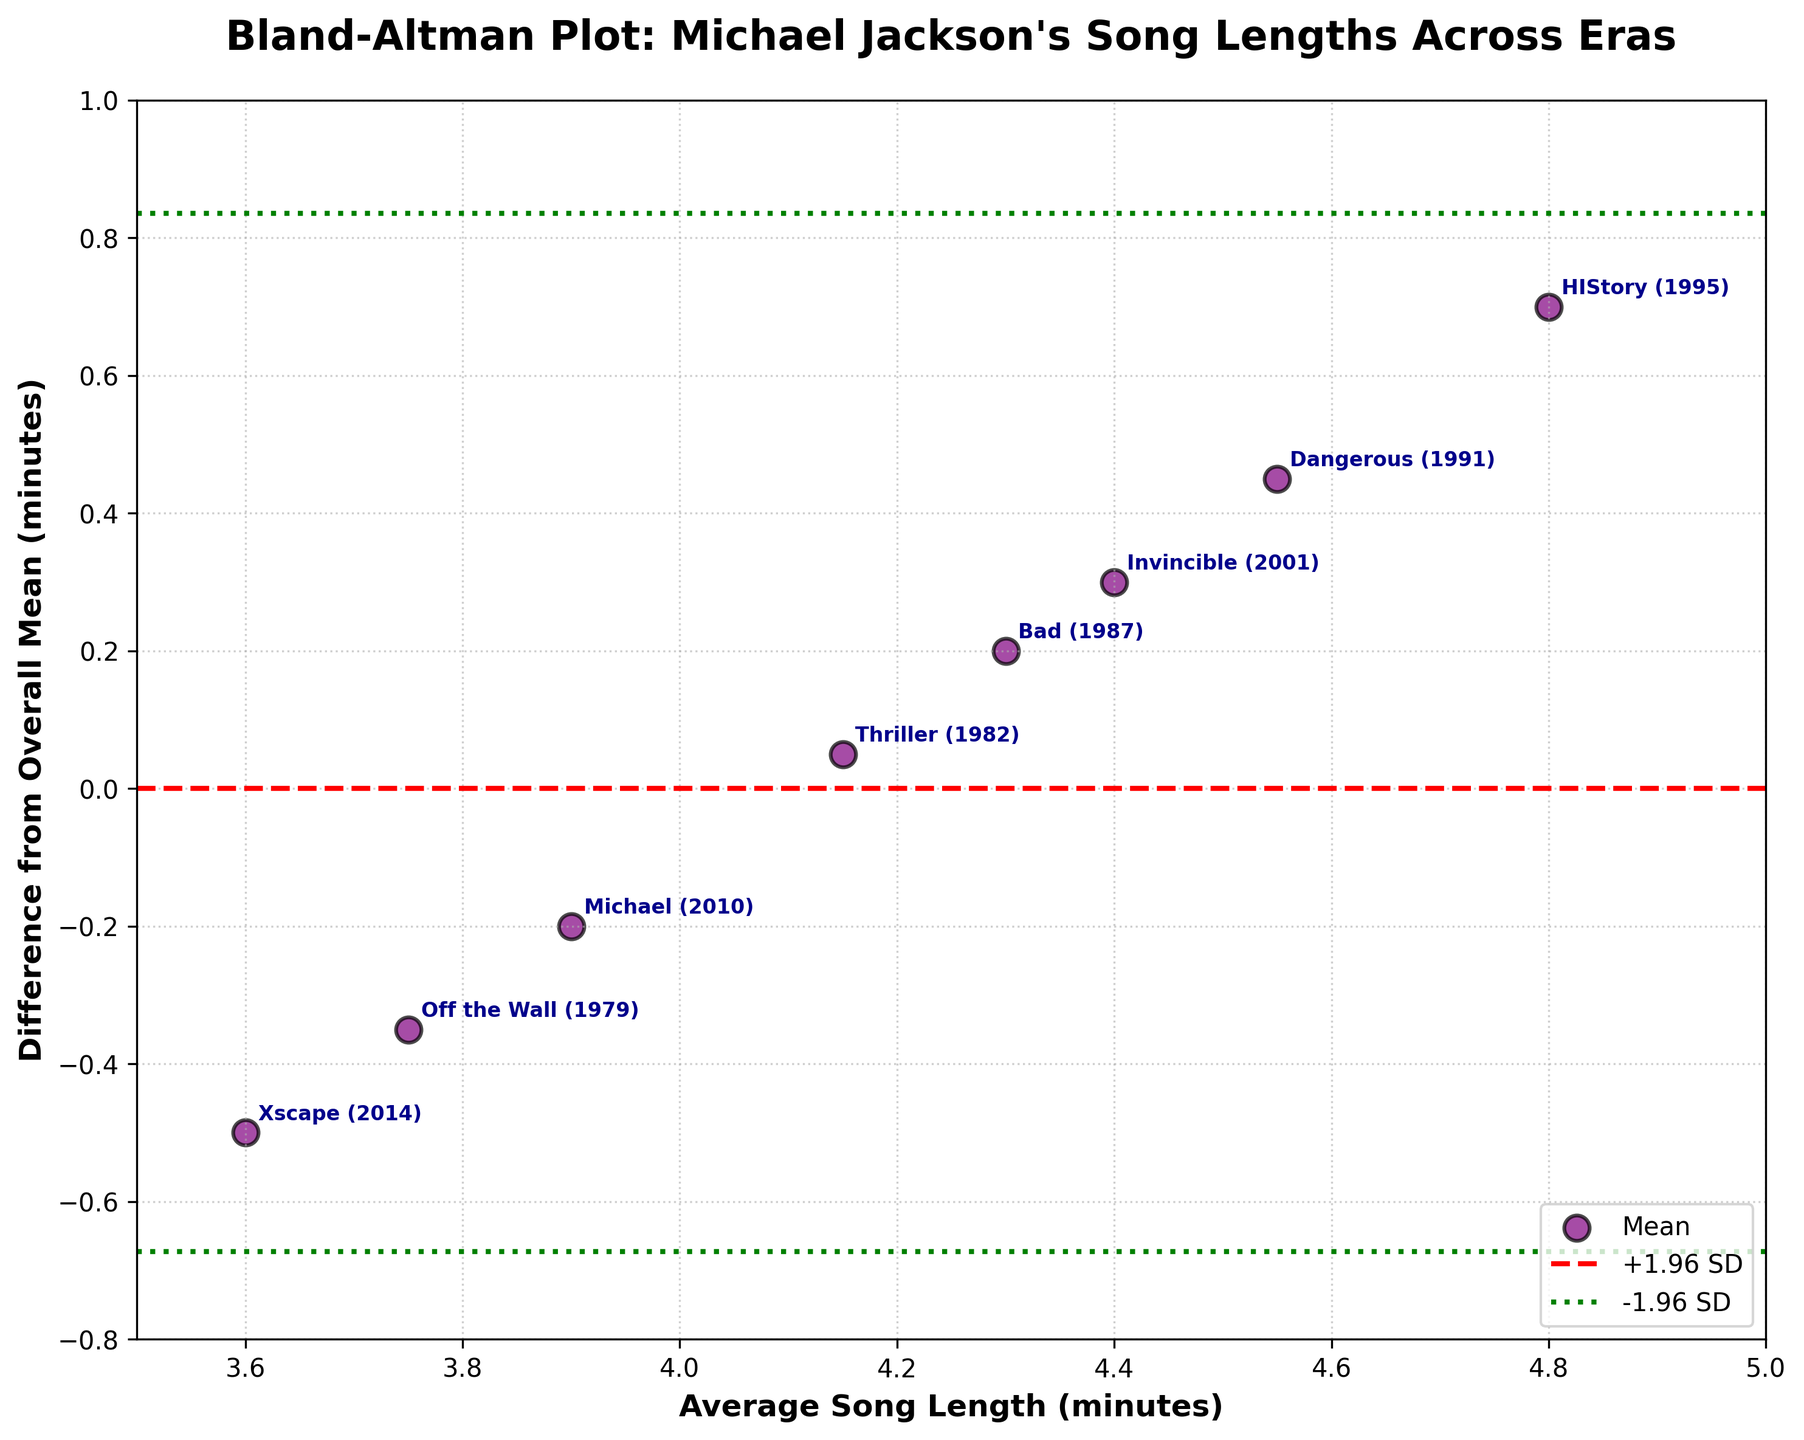How many eras are shown in the plot? Count the number of unique data points plotted on the figure, which represent Michael Jackson's different musical eras.
Answer: 8 What is the title of the plot? Look at the text located at the top of the figure.
Answer: Bland-Altman Plot: Michael Jackson's Song Lengths Across Eras Which era has the largest difference from the overall mean? Identify the era label that corresponds to the highest data point on the y-axis of the plot.
Answer: HIStory (1995) What are the boundaries set by the green dashed lines? Read off the values where the green dashed lines intersect the y-axis. These lines represent +1.96 and -1.96 standard deviations from the mean difference.
Answer: Approximately 0.94 and -0.94 Which eras have a difference from the overall mean below zero? Identify the eras whose points fall below the red dashed line at y=0.
Answer: Off the Wall (1979), Michael (2010), Xscape (2014) Is there any era with an average song length of exactly 4.0 minutes? Look for a data point on the x-axis at the position 4.0 and check if any point is located there.
Answer: No Which has a higher average song length, "Thriller (1982)" or "Bad (1987)"? Compare the positions of the data points labeled "Thriller (1982)" and "Bad (1987)" on the x-axis.
Answer: Bad (1987) What do the red and green dashed lines represent? The red dashed line is at y=0, representing the mean difference, while the green dashed lines represent the limits of agreement at +1.96 and -1.96 standard deviations from the mean difference.
Answer: Mean difference and limits of agreement Does the "Invincible (2001)" era have a longer or shorter average song length compared to the mean? Check the position of the "Invincible (2001)" data point on the y-axis. If it is above the red dashed line, it is longer, otherwise shorter.
Answer: Longer 